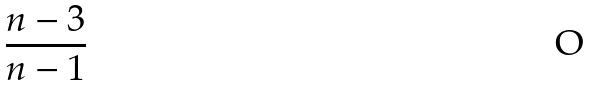Convert formula to latex. <formula><loc_0><loc_0><loc_500><loc_500>\frac { n - 3 } { n - 1 }</formula> 